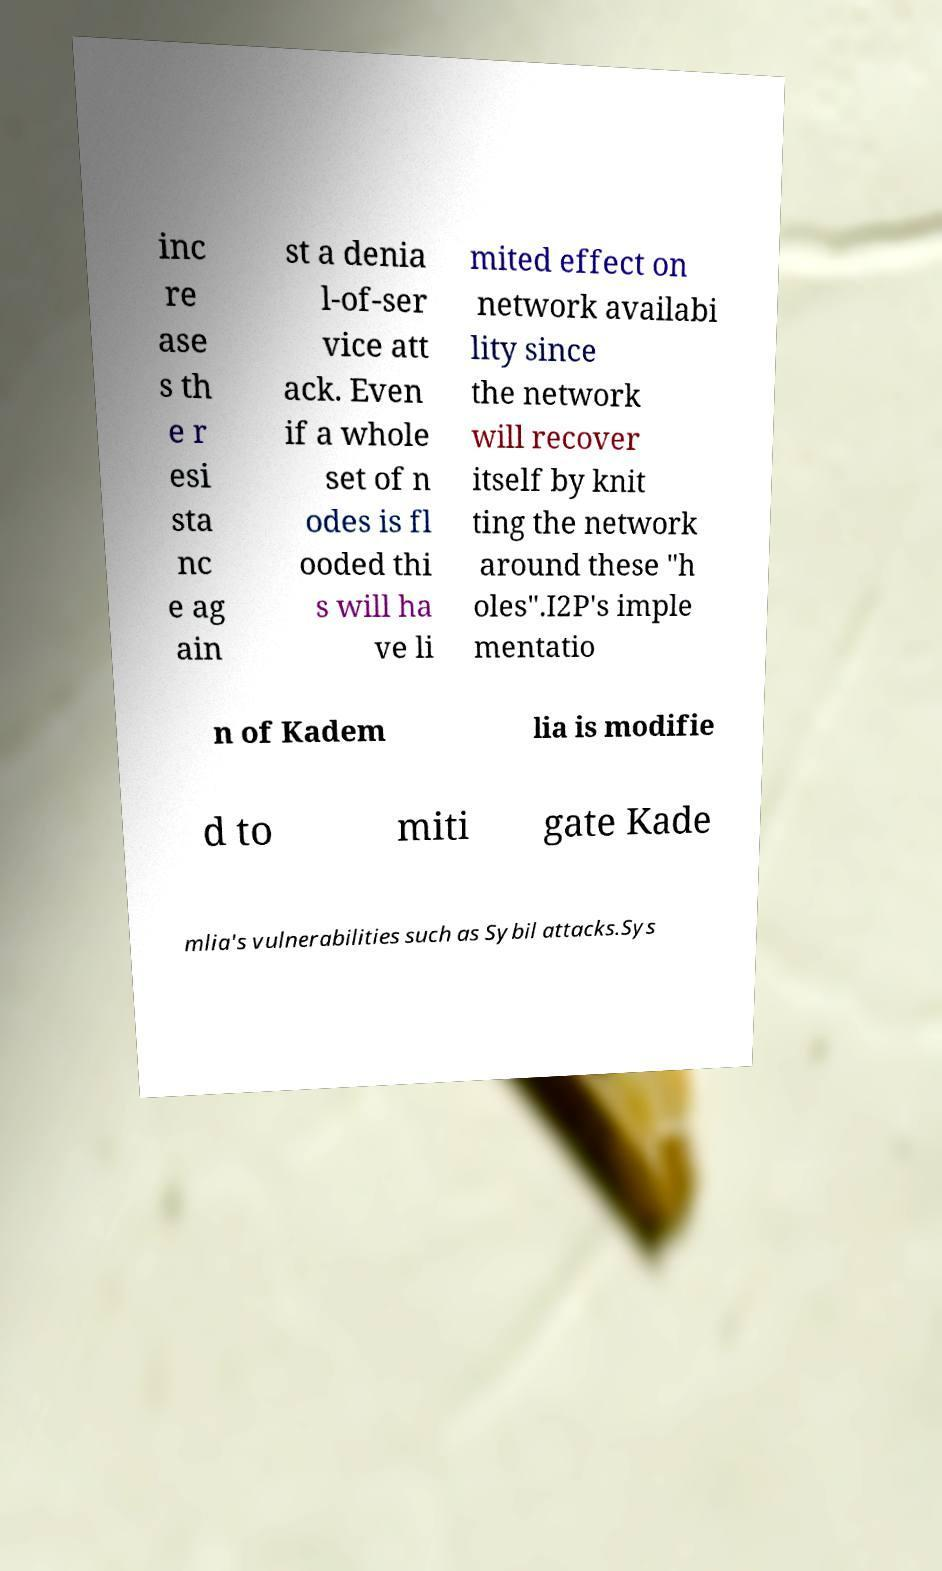What messages or text are displayed in this image? I need them in a readable, typed format. inc re ase s th e r esi sta nc e ag ain st a denia l-of-ser vice att ack. Even if a whole set of n odes is fl ooded thi s will ha ve li mited effect on network availabi lity since the network will recover itself by knit ting the network around these "h oles".I2P's imple mentatio n of Kadem lia is modifie d to miti gate Kade mlia's vulnerabilities such as Sybil attacks.Sys 